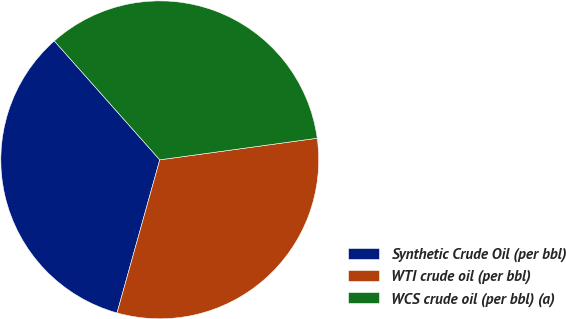Convert chart. <chart><loc_0><loc_0><loc_500><loc_500><pie_chart><fcel>Synthetic Crude Oil (per bbl)<fcel>WTI crude oil (per bbl)<fcel>WCS crude oil (per bbl) (a)<nl><fcel>34.12%<fcel>31.5%<fcel>34.38%<nl></chart> 